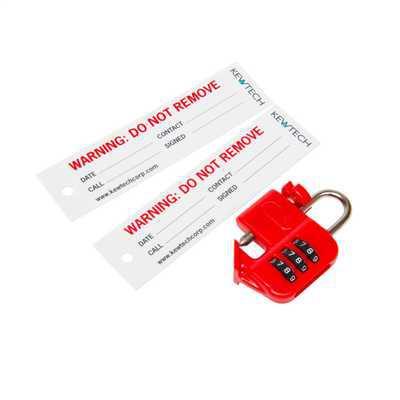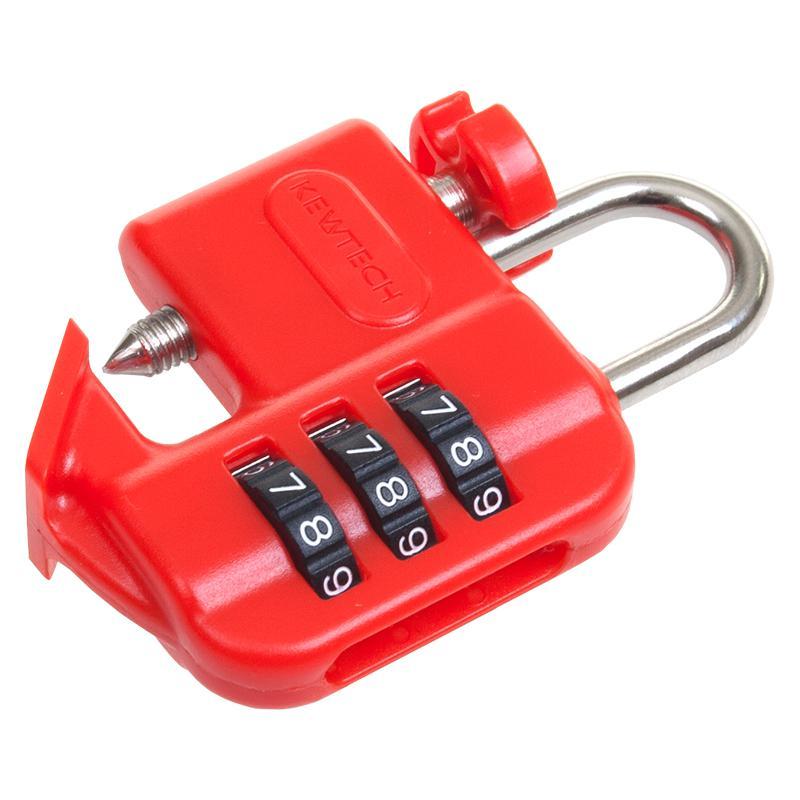The first image is the image on the left, the second image is the image on the right. For the images displayed, is the sentence "There are two warning tags with a red lock." factually correct? Answer yes or no. Yes. 